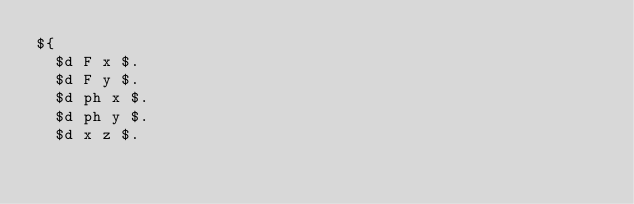Convert code to text. <code><loc_0><loc_0><loc_500><loc_500><_ObjectiveC_>${
  $d F x $.
  $d F y $.
  $d ph x $.
  $d ph y $.
  $d x z $.</code> 